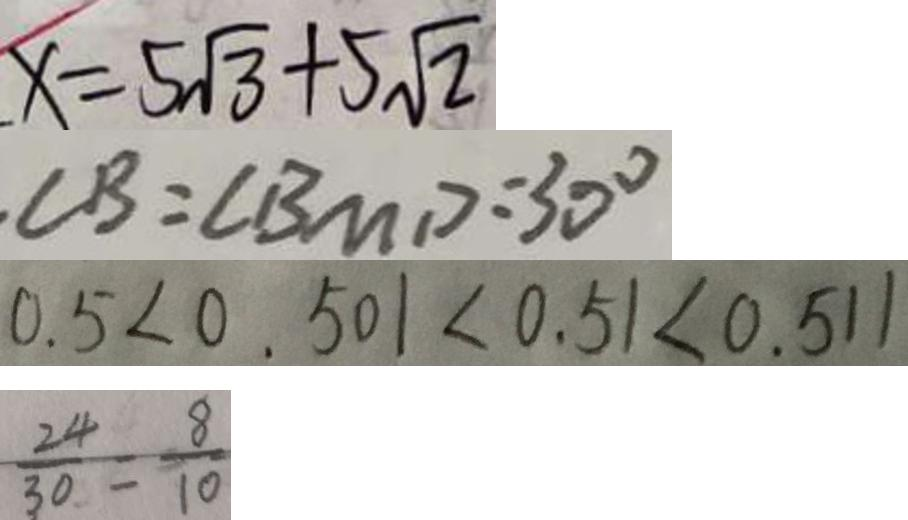<formula> <loc_0><loc_0><loc_500><loc_500>x = 5 \sqrt { 3 } + 5 \sqrt { 2 } 
 . \angle B = \angle B M D = 3 0 ^ { \circ } 
 0 . 5 < 0 . 5 0 1 < 0 . 5 1 < 0 . 5 1 1 
 \frac { 2 4 } { 3 0 } = \frac { 8 } { 1 0 }</formula> 